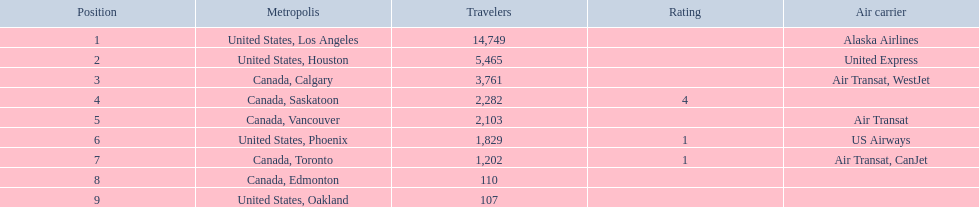Which airline carries the most passengers? Alaska Airlines. 